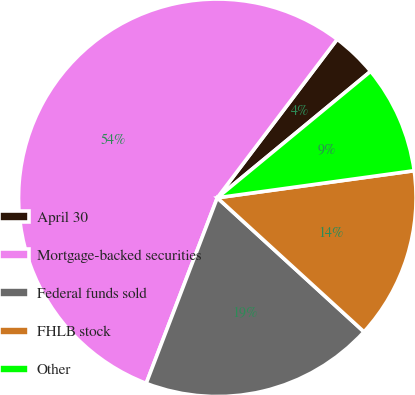<chart> <loc_0><loc_0><loc_500><loc_500><pie_chart><fcel>April 30<fcel>Mortgage-backed securities<fcel>Federal funds sold<fcel>FHLB stock<fcel>Other<nl><fcel>3.72%<fcel>54.48%<fcel>19.04%<fcel>13.96%<fcel>8.8%<nl></chart> 